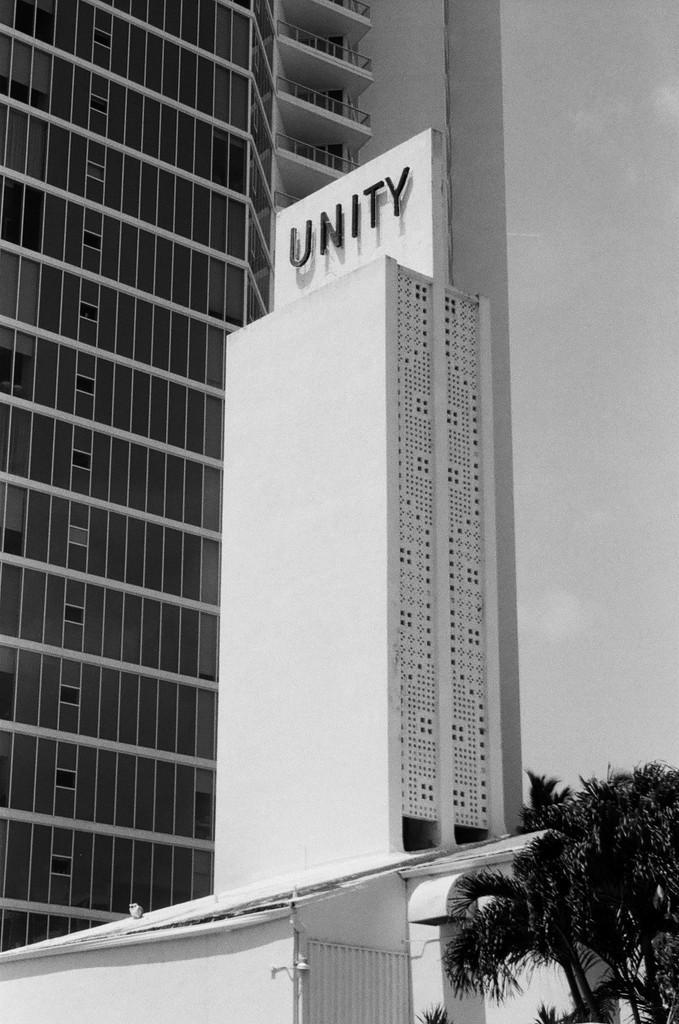How would you summarize this image in a sentence or two? In this picture we can see tall buildings. At the bottom we can see trees. 